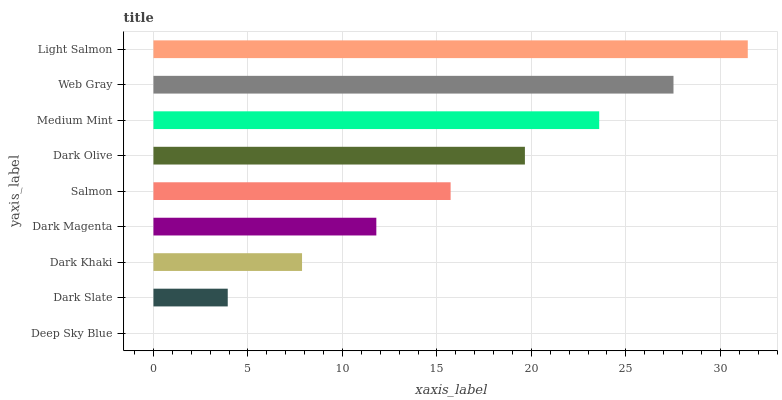Is Deep Sky Blue the minimum?
Answer yes or no. Yes. Is Light Salmon the maximum?
Answer yes or no. Yes. Is Dark Slate the minimum?
Answer yes or no. No. Is Dark Slate the maximum?
Answer yes or no. No. Is Dark Slate greater than Deep Sky Blue?
Answer yes or no. Yes. Is Deep Sky Blue less than Dark Slate?
Answer yes or no. Yes. Is Deep Sky Blue greater than Dark Slate?
Answer yes or no. No. Is Dark Slate less than Deep Sky Blue?
Answer yes or no. No. Is Salmon the high median?
Answer yes or no. Yes. Is Salmon the low median?
Answer yes or no. Yes. Is Light Salmon the high median?
Answer yes or no. No. Is Dark Olive the low median?
Answer yes or no. No. 